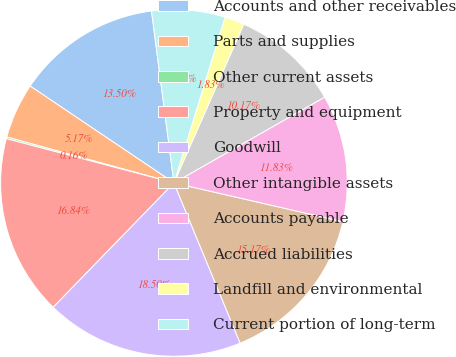Convert chart to OTSL. <chart><loc_0><loc_0><loc_500><loc_500><pie_chart><fcel>Accounts and other receivables<fcel>Parts and supplies<fcel>Other current assets<fcel>Property and equipment<fcel>Goodwill<fcel>Other intangible assets<fcel>Accounts payable<fcel>Accrued liabilities<fcel>Landfill and environmental<fcel>Current portion of long-term<nl><fcel>13.5%<fcel>5.17%<fcel>0.16%<fcel>16.84%<fcel>18.5%<fcel>15.17%<fcel>11.83%<fcel>10.17%<fcel>1.83%<fcel>6.83%<nl></chart> 